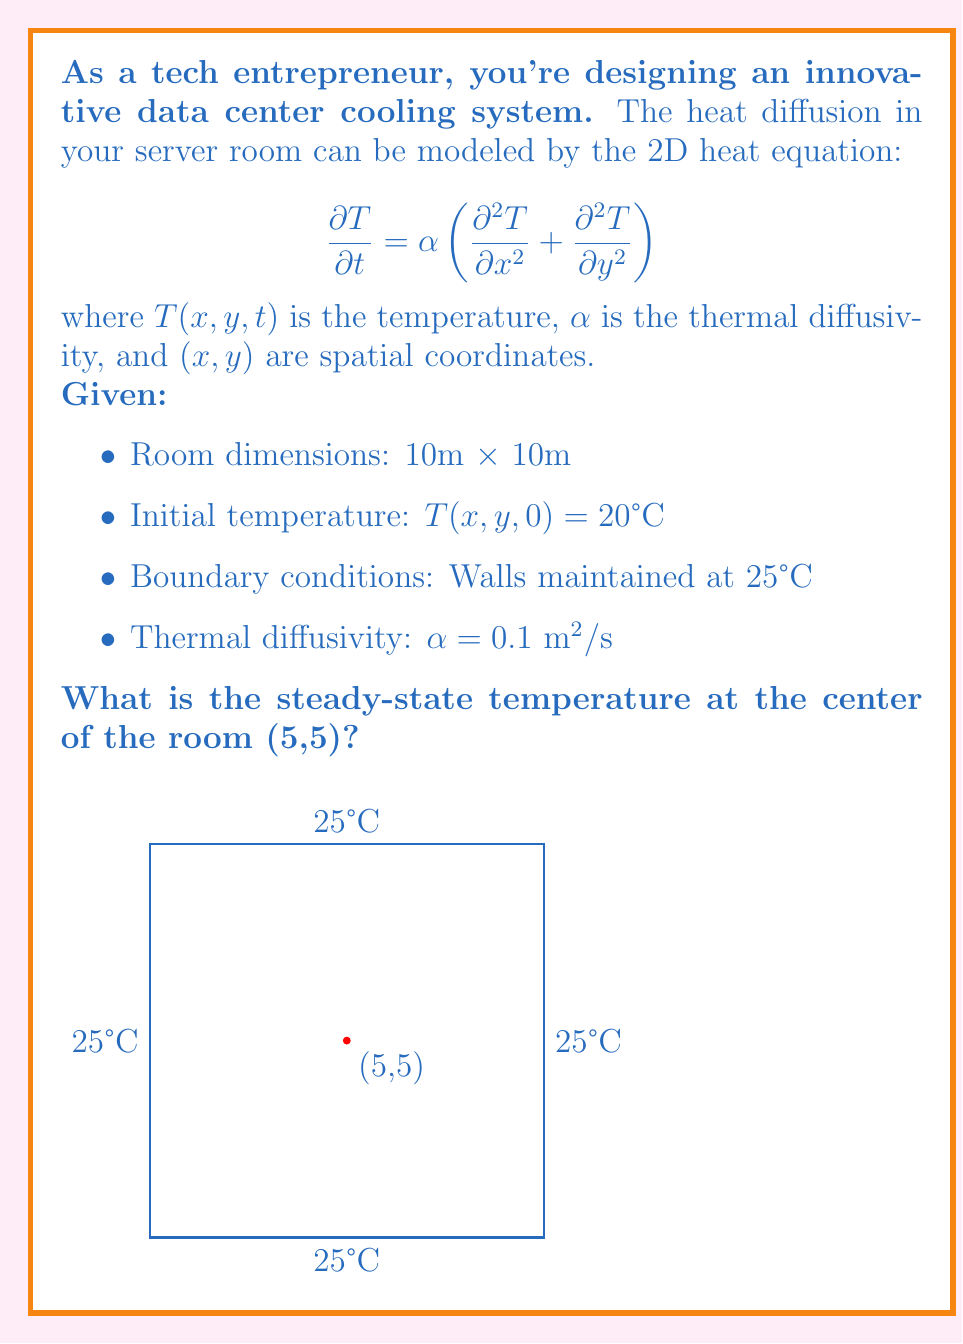Can you answer this question? To solve this problem, we'll follow these steps:

1) For steady-state, the temperature doesn't change with time, so $\frac{\partial T}{\partial t} = 0$. The heat equation reduces to:

   $$\frac{\partial^2 T}{\partial x^2} + \frac{\partial^2 T}{\partial y^2} = 0$$

   This is Laplace's equation in 2D.

2) Given the symmetry of the problem (square room with uniform boundary conditions), we can deduce that the steady-state solution will be constant throughout the room.

3) Let's call this constant temperature $T_s$. Since it's constant, its derivatives are zero:

   $$\frac{\partial^2 T_s}{\partial x^2} = \frac{\partial^2 T_s}{\partial y^2} = 0$$

4) This constant $T_s$ must satisfy the boundary conditions. All walls are maintained at 25°C, so:

   $$T_s = 25°C$$

5) Therefore, at steady-state, the entire room, including the center point (5,5), will be at 25°C.

This result makes intuitive sense: with constant temperature boundaries and no internal heat sources, the room will eventually reach a uniform temperature equal to that of the boundaries.
Answer: 25°C 